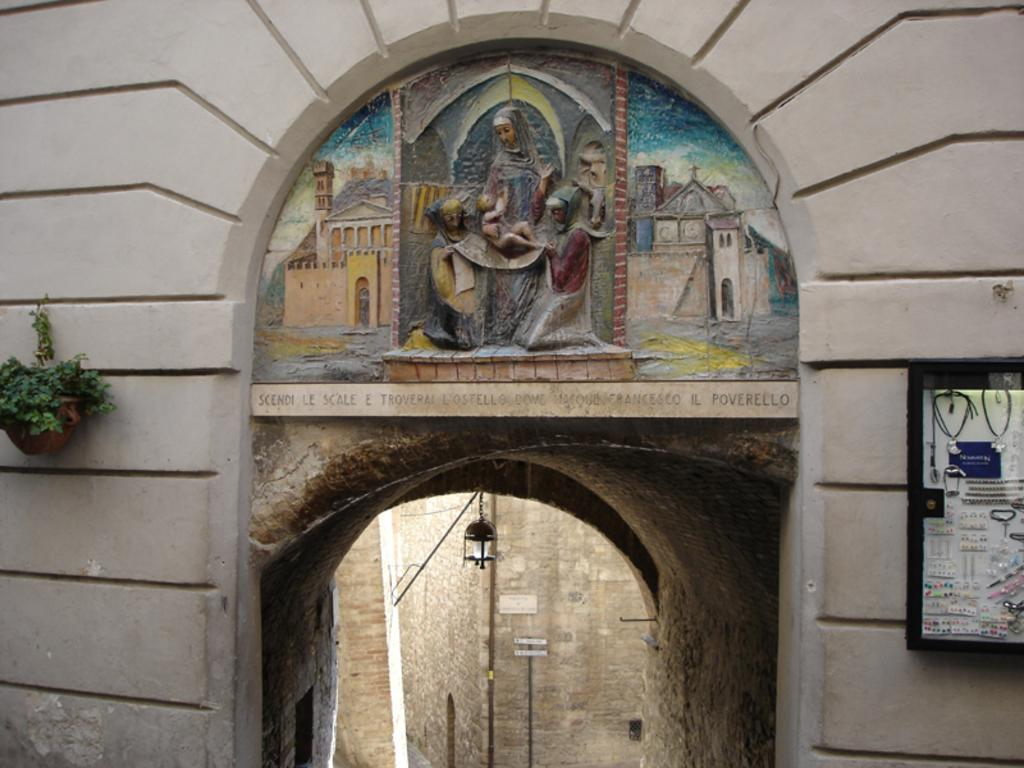What type of structure can be seen in the image? There is an entrance wall in the image. What decorative elements are on top of the entrance wall? Sculptures are present on top of the entrance wall. What type of plant is visible in the image? There is a houseplant in the image. How is the houseplant positioned in the image? The houseplant is hanged on the wall. What type of fan is used to cool the sculptures in the image? There is no fan present in the image, and the sculptures do not require cooling. 